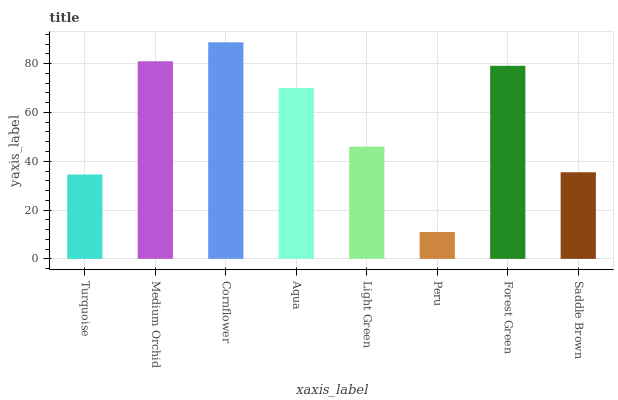Is Peru the minimum?
Answer yes or no. Yes. Is Cornflower the maximum?
Answer yes or no. Yes. Is Medium Orchid the minimum?
Answer yes or no. No. Is Medium Orchid the maximum?
Answer yes or no. No. Is Medium Orchid greater than Turquoise?
Answer yes or no. Yes. Is Turquoise less than Medium Orchid?
Answer yes or no. Yes. Is Turquoise greater than Medium Orchid?
Answer yes or no. No. Is Medium Orchid less than Turquoise?
Answer yes or no. No. Is Aqua the high median?
Answer yes or no. Yes. Is Light Green the low median?
Answer yes or no. Yes. Is Light Green the high median?
Answer yes or no. No. Is Medium Orchid the low median?
Answer yes or no. No. 